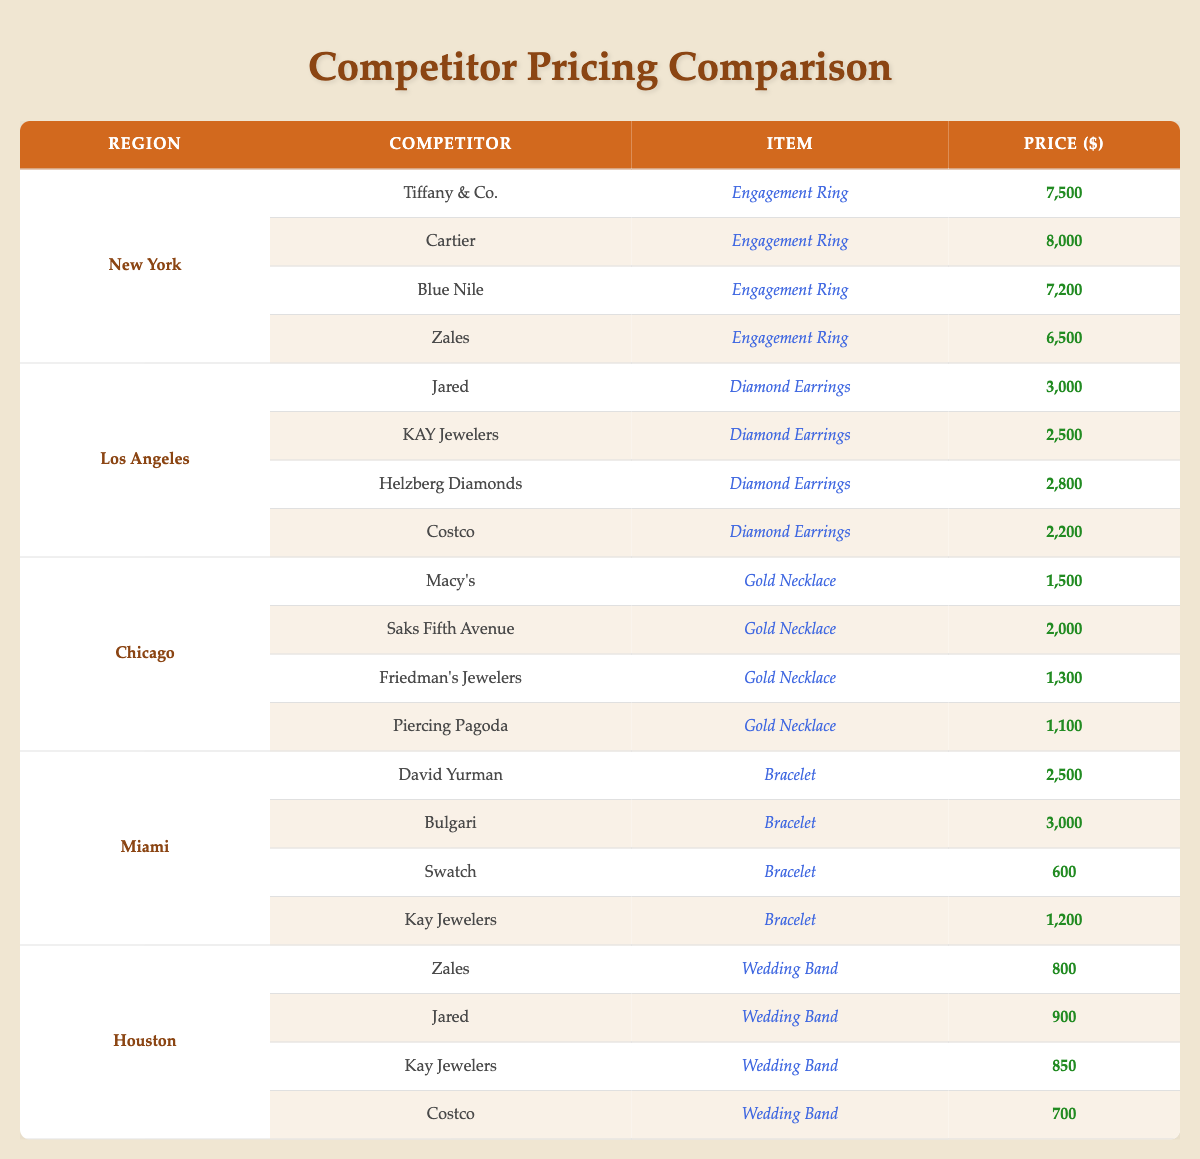What is the price of the Engagement Ring offered by Cartier in New York? The table shows that Cartier offers an Engagement Ring in New York for 8,000 dollars.
Answer: 8,000 Which competitor has the lowest price for Gold Necklaces in Chicago? In Chicago, Piercing Pagoda has the lowest price for Gold Necklaces at 1,100 dollars, with the other prices being higher.
Answer: Piercing Pagoda What is the price difference between the most expensive and the least expensive Diamond Earrings in Los Angeles? The most expensive Diamond Earrings are from Jared at 3,000 dollars and the least expensive from Costco at 2,200 dollars. The difference is 3,000 - 2,200 = 800 dollars.
Answer: 800 True or False: Zales offers the same type of item in both New York and Houston. Zales offers Engagement Rings in New York and Wedding Bands in Houston, which are different items. Therefore, the statement is false.
Answer: False What is the average price of Wedding Bands in Houston? The prices for Wedding Bands in Houston are 800, 900, 850, and 700 dollars. First, sum these: 800 + 900 + 850 + 700 = 3,250. Then divide by the number of items (4): 3,250 / 4 = 812.5 dollars.
Answer: 812.5 Which competitor has the highest price for a Bracelet in Miami? In Miami, Bulgari has the highest price for a Bracelet at 3,000 dollars, while the other competitors offer lower prices.
Answer: Bulgari What is the median price of Engagement Rings in New York? The prices for Engagement Rings in New York are 8,000, 7,500, 7,200, and 6,500 dollars. Arranging these in order gives us 6,500, 7,200, 7,500, and 8,000. The median is the average of the two middle numbers: (7,200 + 7,500) / 2 = 7,350 dollars.
Answer: 7,350 In which region is Kay Jewelers offering the lowest-priced item? Kay Jewelers offers Bracelets for 1,200 dollars in Miami and Wedding Bands for 850 dollars in Houston. The lower price is the Wedding Band in Houston at 850 dollars.
Answer: Houston How much more does Tiffany & Co. charge compared to Blue Nile for Engagement Rings in New York? Tiffany & Co. charges 7,500 dollars while Blue Nile charges 7,200 dollars. The difference is 7,500 - 7,200 = 300 dollars.
Answer: 300 Which competitor offers the second-most expensive Gold Necklace in Chicago? In Chicago, the second-most expensive Gold Necklace is offered by Saks Fifth Avenue for 2,000 dollars, after Macy's at 1,500 dollars.
Answer: Saks Fifth Avenue 